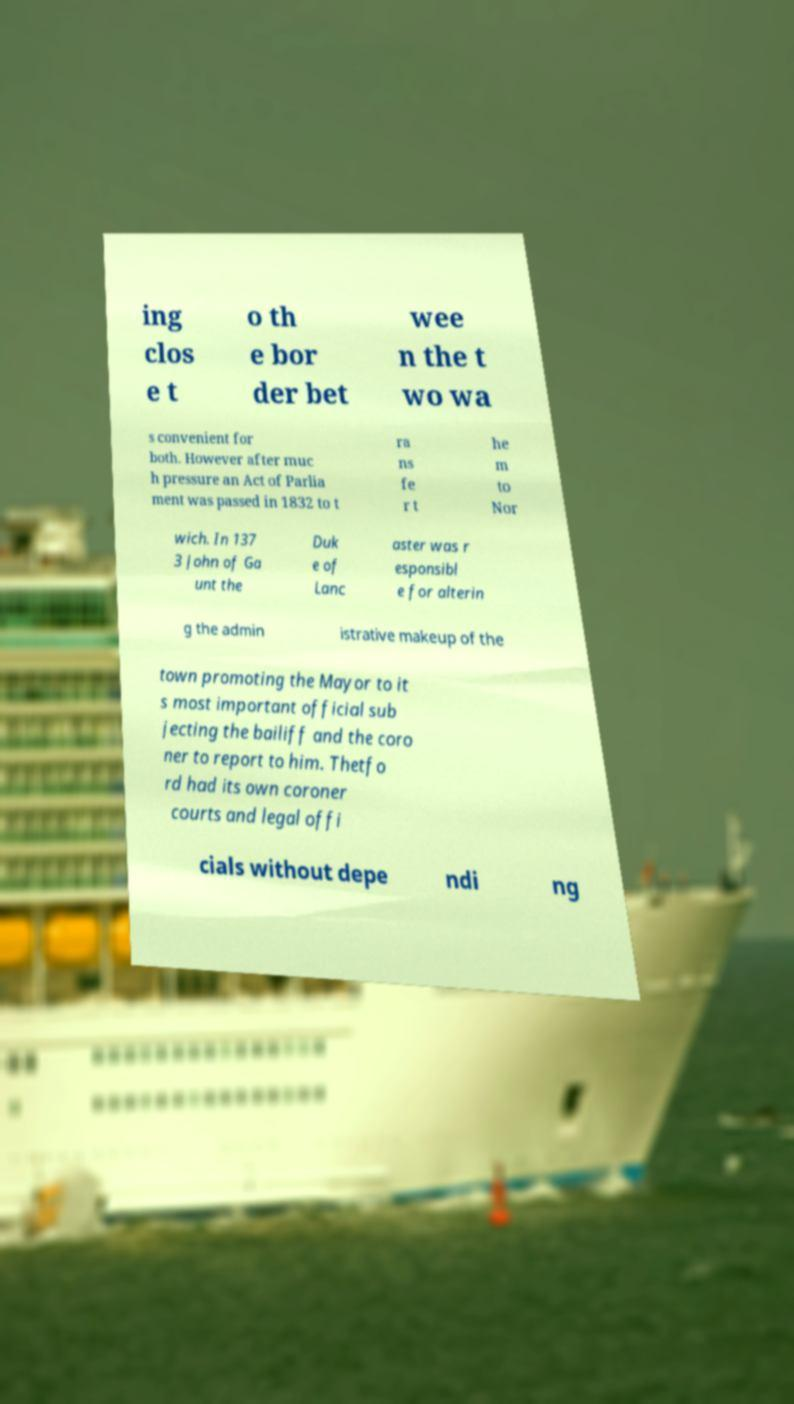For documentation purposes, I need the text within this image transcribed. Could you provide that? ing clos e t o th e bor der bet wee n the t wo wa s convenient for both. However after muc h pressure an Act of Parlia ment was passed in 1832 to t ra ns fe r t he m to Nor wich. In 137 3 John of Ga unt the Duk e of Lanc aster was r esponsibl e for alterin g the admin istrative makeup of the town promoting the Mayor to it s most important official sub jecting the bailiff and the coro ner to report to him. Thetfo rd had its own coroner courts and legal offi cials without depe ndi ng 